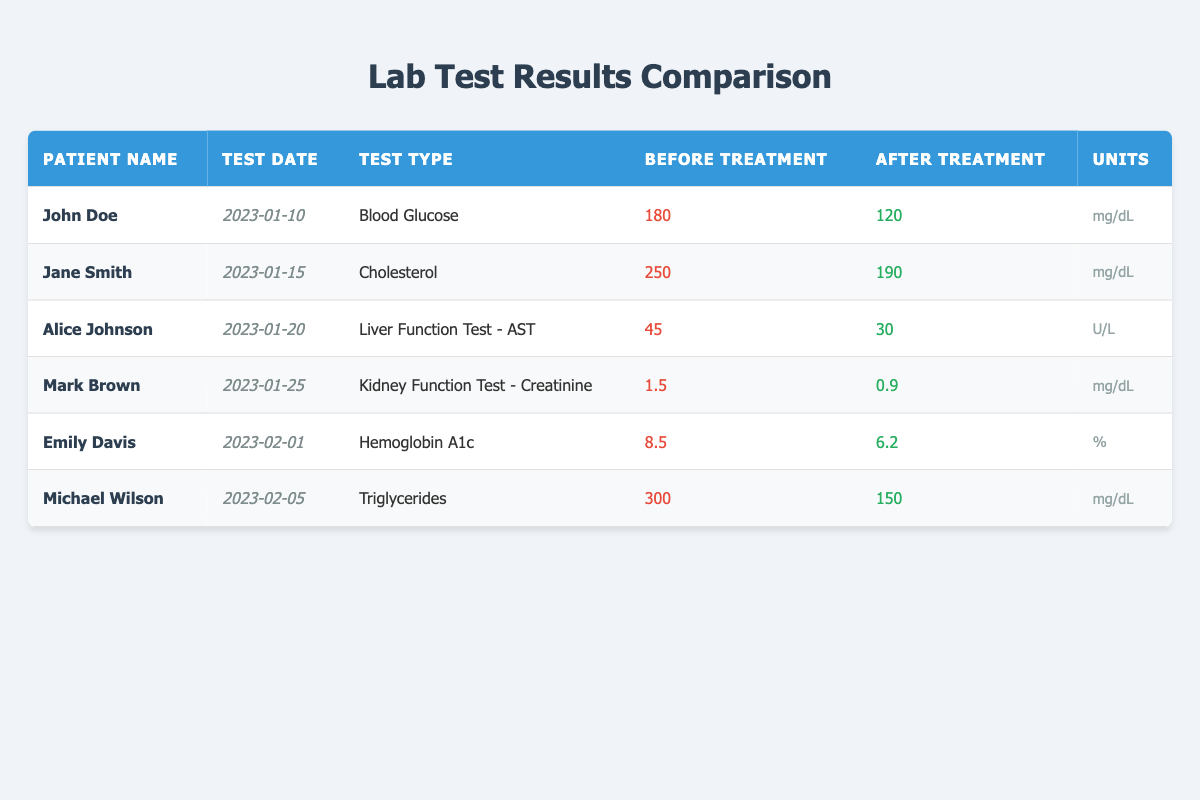What was John Doe's blood glucose level after treatment? The table shows that John Doe's blood glucose level after treatment was 120 mg/dL, as indicated in the "After Treatment" column for his test type.
Answer: 120 mg/dL Which patient had the highest before-treatment cholesterol level? Referring to the "Before Treatment" column, Jane Smith had the highest cholesterol level at 250 mg/dL, making her the patient with the highest level before treatment.
Answer: Jane Smith What is the difference in liver function test AST levels before and after treatment for Alice Johnson? For Alice Johnson, the before treatment level is 45 U/L and the after treatment level is 30 U/L. The difference is calculated as 45 - 30 = 15 U/L.
Answer: 15 U/L Did Michael Wilson's triglyceride level decrease after treatment? Yes, Michael Wilson's triglyceride level before treatment was 300 mg/dL, and after treatment it was 150 mg/dL, confirming that the level decreased.
Answer: Yes What is the average before-treatment blood glucose level for all patients? The before-treatment levels for all patients are 180, 250, 45, 1.5, 8.5, and 300. Summing these gives 180 + 250 + 45 + 1.5 + 8.5 + 300 = 785. There are 6 patients, so the average is 785 / 6 = 130.83 mg/dL.
Answer: 130.83 mg/dL Which patient showed the most significant improvement in their test after treatment? To determine the largest improvement, we calculate the difference for each patient: John Doe (60), Jane Smith (60), Alice Johnson (15), Mark Brown (0.6), Emily Davis (2.3), Michael Wilson (150). John Doe and Jane Smith both improved by 60 mg/dL. Therefore, the most significant improvement is from either John Doe or Jane Smith, who both displayed significant results.
Answer: John Doe and Jane Smith How many patients had an after-treatment level below 100? Referring to the "After Treatment" column, only Mark Brown showed a result below 100, as he had an after-treatment level of 0.9 mg/dL. Therefore, only one patient met this criterion.
Answer: One patient Was Emily Davis's hemoglobin A1c level above the normal range before treatment? Yes, Emily Davis's before-treatment level for hemoglobin A1c was 8.5%, which is generally considered above the normal range (usually below 7%).
Answer: Yes 